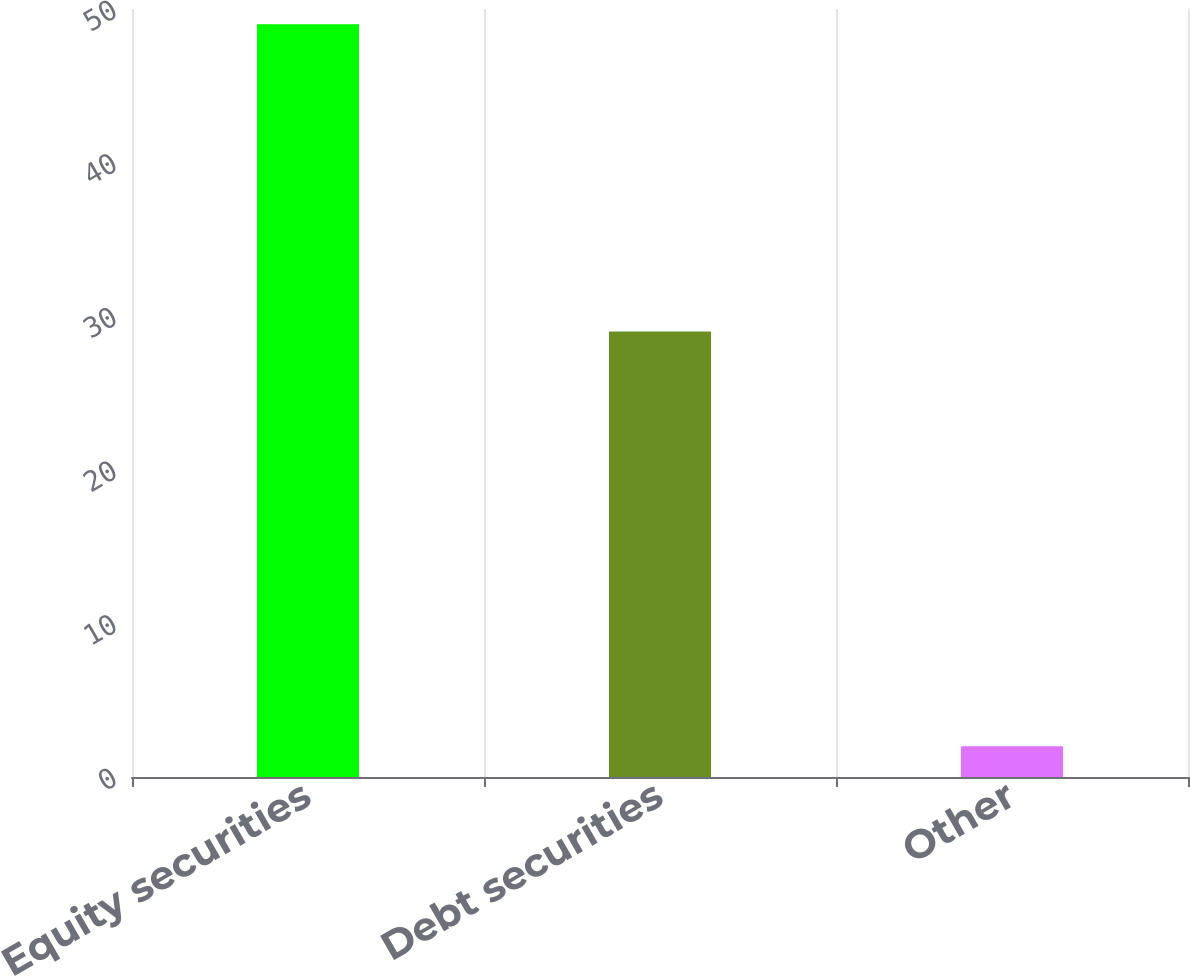Convert chart. <chart><loc_0><loc_0><loc_500><loc_500><bar_chart><fcel>Equity securities<fcel>Debt securities<fcel>Other<nl><fcel>49<fcel>29<fcel>2<nl></chart> 